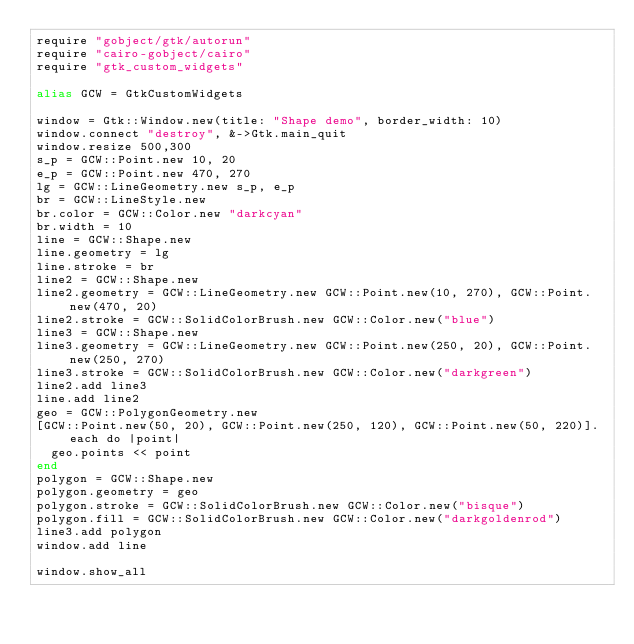Convert code to text. <code><loc_0><loc_0><loc_500><loc_500><_Crystal_>require "gobject/gtk/autorun"
require "cairo-gobject/cairo"
require "gtk_custom_widgets"

alias GCW = GtkCustomWidgets

window = Gtk::Window.new(title: "Shape demo", border_width: 10)
window.connect "destroy", &->Gtk.main_quit
window.resize 500,300
s_p = GCW::Point.new 10, 20
e_p = GCW::Point.new 470, 270
lg = GCW::LineGeometry.new s_p, e_p
br = GCW::LineStyle.new
br.color = GCW::Color.new "darkcyan"
br.width = 10
line = GCW::Shape.new
line.geometry = lg
line.stroke = br
line2 = GCW::Shape.new
line2.geometry = GCW::LineGeometry.new GCW::Point.new(10, 270), GCW::Point.new(470, 20)
line2.stroke = GCW::SolidColorBrush.new GCW::Color.new("blue")
line3 = GCW::Shape.new
line3.geometry = GCW::LineGeometry.new GCW::Point.new(250, 20), GCW::Point.new(250, 270)
line3.stroke = GCW::SolidColorBrush.new GCW::Color.new("darkgreen")
line2.add line3
line.add line2
geo = GCW::PolygonGeometry.new
[GCW::Point.new(50, 20), GCW::Point.new(250, 120), GCW::Point.new(50, 220)].each do |point|
  geo.points << point
end 
polygon = GCW::Shape.new 
polygon.geometry = geo
polygon.stroke = GCW::SolidColorBrush.new GCW::Color.new("bisque")
polygon.fill = GCW::SolidColorBrush.new GCW::Color.new("darkgoldenrod")
line3.add polygon
window.add line

window.show_all

</code> 